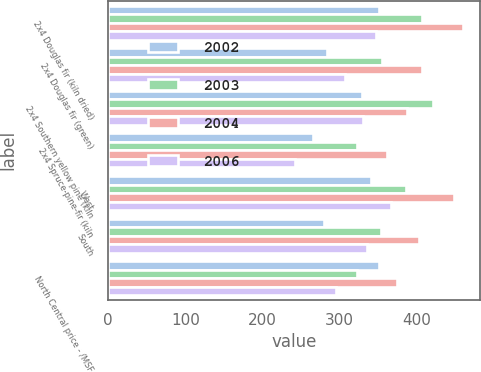Convert chart to OTSL. <chart><loc_0><loc_0><loc_500><loc_500><stacked_bar_chart><ecel><fcel>2x4 Douglas fir (kiln dried)<fcel>2x4 Douglas fir (green)<fcel>2x4 Southern yellow pine (kiln<fcel>2x4 Spruce-pine-fir (kiln<fcel>West<fcel>South<fcel>North Central price - /MSF<nl><fcel>2002<fcel>351<fcel>284<fcel>329<fcel>265<fcel>341<fcel>279<fcel>351<nl><fcel>2003<fcel>406<fcel>355<fcel>421<fcel>322<fcel>386<fcel>353<fcel>323<nl><fcel>2004<fcel>459<fcel>406<fcel>387<fcel>361<fcel>448<fcel>403<fcel>374<nl><fcel>2006<fcel>347<fcel>307<fcel>330<fcel>242<fcel>367<fcel>335<fcel>295<nl></chart> 